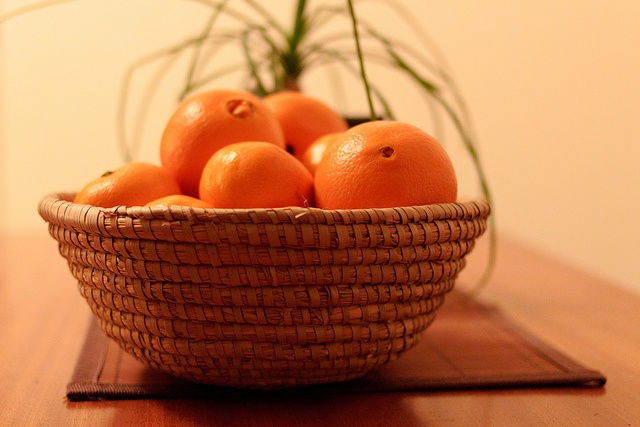Describe the objects in this image and their specific colors. I can see dining table in tan and red tones, bowl in tan, maroon, black, and brown tones, orange in tan, red, and orange tones, potted plant in tan and olive tones, and orange in tan, red, and orange tones in this image. 